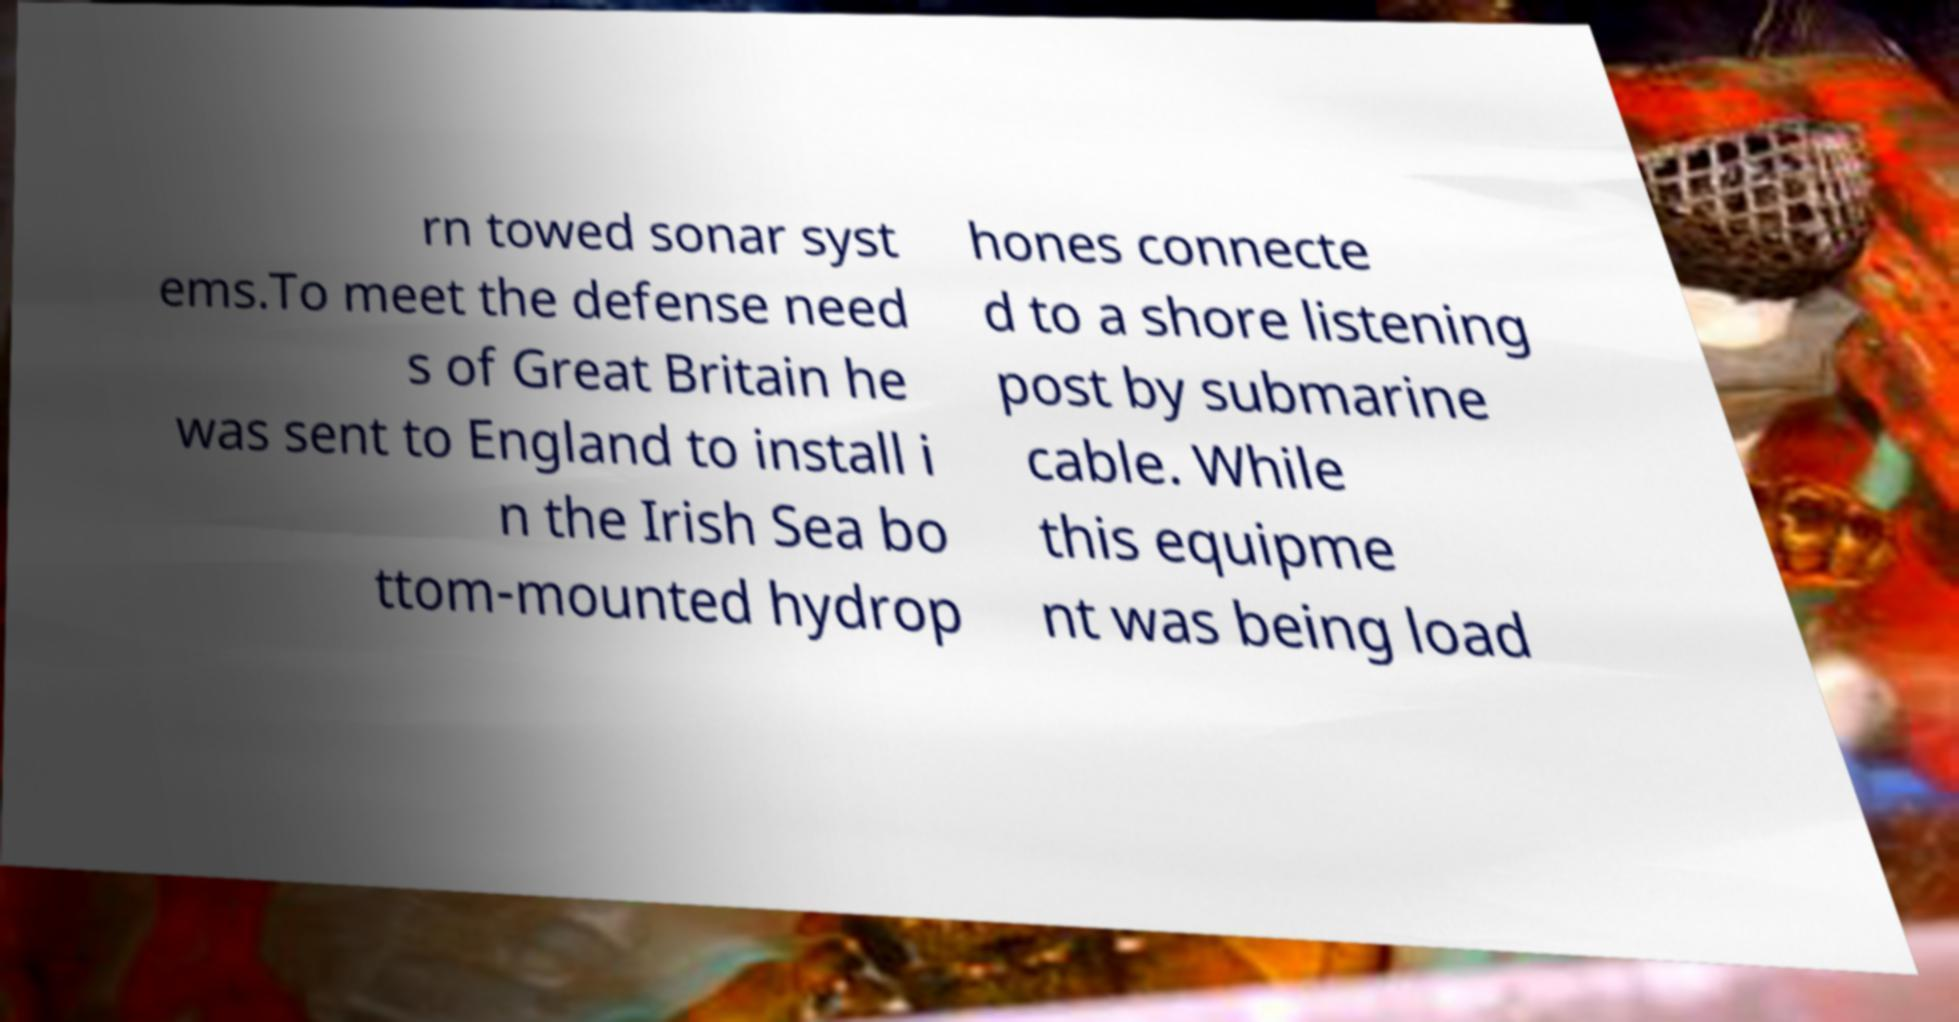Please read and relay the text visible in this image. What does it say? rn towed sonar syst ems.To meet the defense need s of Great Britain he was sent to England to install i n the Irish Sea bo ttom-mounted hydrop hones connecte d to a shore listening post by submarine cable. While this equipme nt was being load 